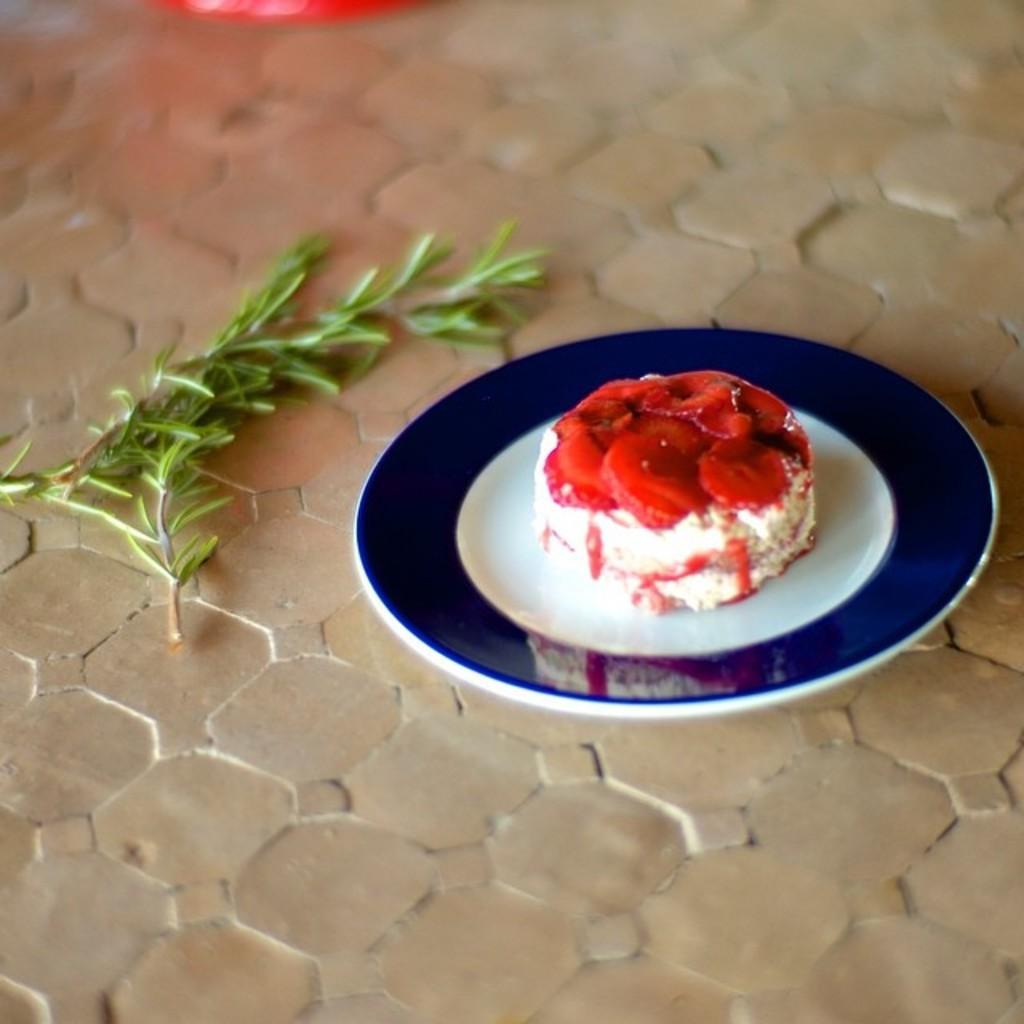Could you give a brief overview of what you see in this image? This image consists of food which is on the plate in the center. On the left side of the plate there are leaves and on the top there is an object which is red in colour. 